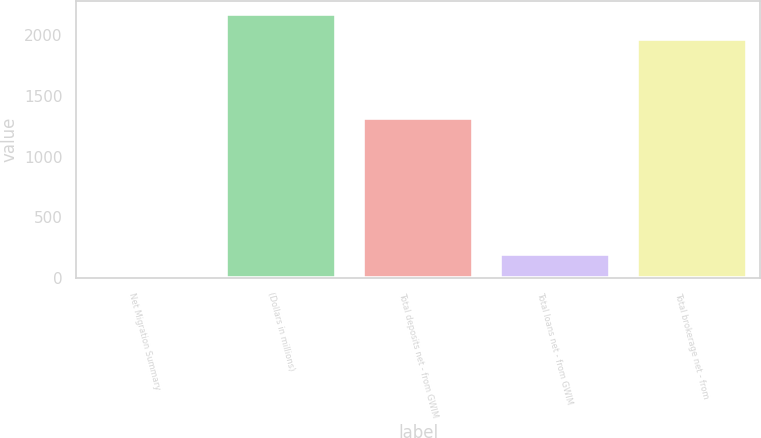<chart> <loc_0><loc_0><loc_500><loc_500><bar_chart><fcel>Net Migration Summary<fcel>(Dollars in millions)<fcel>Total deposits net - from GWIM<fcel>Total loans net - from GWIM<fcel>Total brokerage net - from<nl><fcel>1<fcel>2173.5<fcel>1319<fcel>202.5<fcel>1972<nl></chart> 